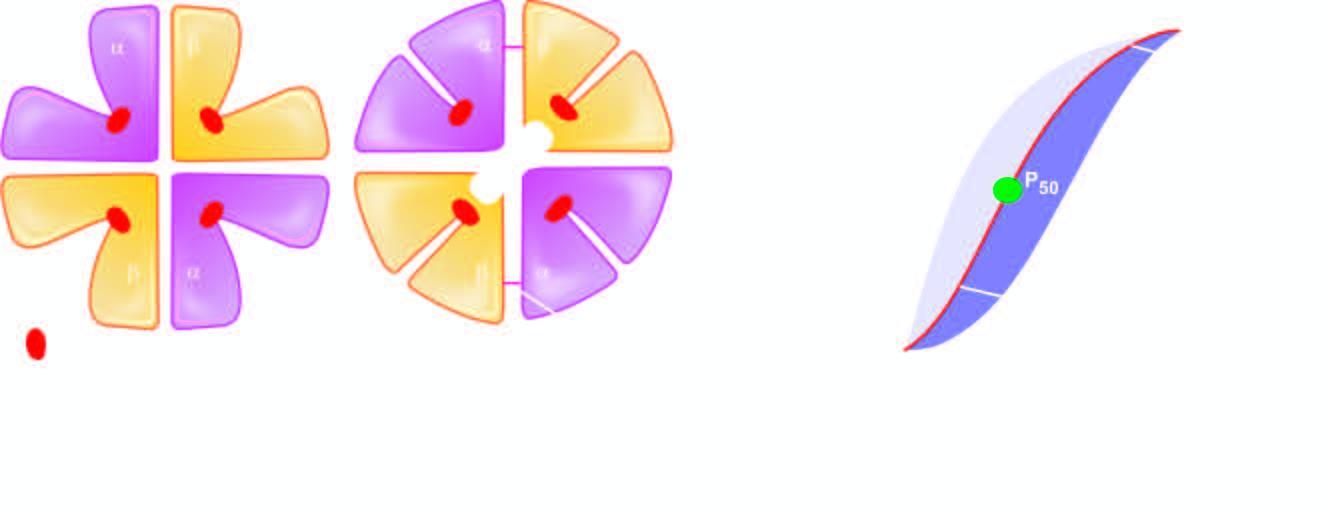s oxygen delivery less with high ph, low 2,3-bpg and hbf?
Answer the question using a single word or phrase. Yes 